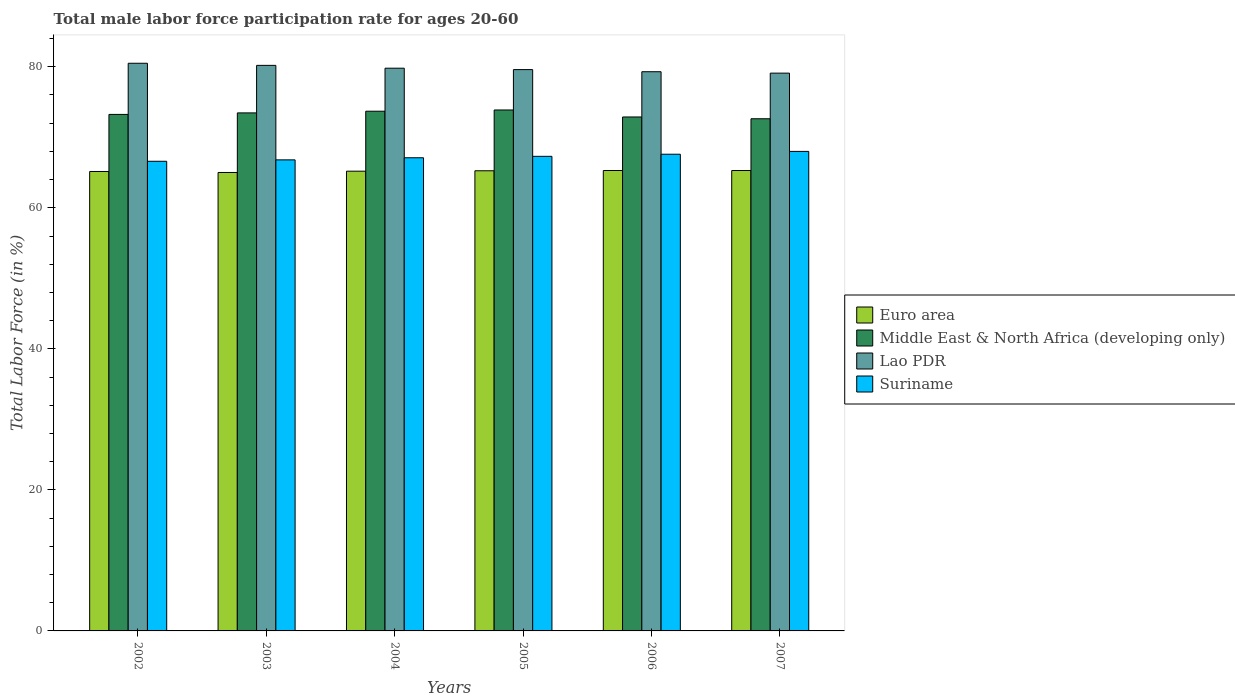How many groups of bars are there?
Your answer should be compact. 6. How many bars are there on the 5th tick from the left?
Give a very brief answer. 4. What is the male labor force participation rate in Euro area in 2003?
Make the answer very short. 65.01. Across all years, what is the maximum male labor force participation rate in Middle East & North Africa (developing only)?
Keep it short and to the point. 73.88. Across all years, what is the minimum male labor force participation rate in Suriname?
Your response must be concise. 66.6. In which year was the male labor force participation rate in Suriname maximum?
Ensure brevity in your answer.  2007. In which year was the male labor force participation rate in Euro area minimum?
Give a very brief answer. 2003. What is the total male labor force participation rate in Suriname in the graph?
Provide a succinct answer. 403.4. What is the difference between the male labor force participation rate in Middle East & North Africa (developing only) in 2006 and that in 2007?
Your answer should be very brief. 0.25. What is the difference between the male labor force participation rate in Euro area in 2006 and the male labor force participation rate in Suriname in 2004?
Keep it short and to the point. -1.81. What is the average male labor force participation rate in Suriname per year?
Your answer should be compact. 67.23. In the year 2002, what is the difference between the male labor force participation rate in Suriname and male labor force participation rate in Euro area?
Offer a terse response. 1.45. What is the ratio of the male labor force participation rate in Middle East & North Africa (developing only) in 2006 to that in 2007?
Your answer should be compact. 1. What is the difference between the highest and the second highest male labor force participation rate in Middle East & North Africa (developing only)?
Provide a short and direct response. 0.17. What is the difference between the highest and the lowest male labor force participation rate in Euro area?
Give a very brief answer. 0.28. Is it the case that in every year, the sum of the male labor force participation rate in Middle East & North Africa (developing only) and male labor force participation rate in Suriname is greater than the sum of male labor force participation rate in Lao PDR and male labor force participation rate in Euro area?
Your answer should be very brief. Yes. What does the 4th bar from the left in 2005 represents?
Your answer should be compact. Suriname. Is it the case that in every year, the sum of the male labor force participation rate in Middle East & North Africa (developing only) and male labor force participation rate in Suriname is greater than the male labor force participation rate in Euro area?
Your answer should be very brief. Yes. How many bars are there?
Offer a very short reply. 24. Are the values on the major ticks of Y-axis written in scientific E-notation?
Give a very brief answer. No. Does the graph contain any zero values?
Offer a very short reply. No. Does the graph contain grids?
Your response must be concise. No. Where does the legend appear in the graph?
Ensure brevity in your answer.  Center right. How are the legend labels stacked?
Provide a succinct answer. Vertical. What is the title of the graph?
Keep it short and to the point. Total male labor force participation rate for ages 20-60. Does "Liberia" appear as one of the legend labels in the graph?
Keep it short and to the point. No. What is the Total Labor Force (in %) of Euro area in 2002?
Your response must be concise. 65.15. What is the Total Labor Force (in %) in Middle East & North Africa (developing only) in 2002?
Your response must be concise. 73.25. What is the Total Labor Force (in %) in Lao PDR in 2002?
Your response must be concise. 80.5. What is the Total Labor Force (in %) in Suriname in 2002?
Provide a succinct answer. 66.6. What is the Total Labor Force (in %) of Euro area in 2003?
Your answer should be very brief. 65.01. What is the Total Labor Force (in %) of Middle East & North Africa (developing only) in 2003?
Offer a terse response. 73.46. What is the Total Labor Force (in %) in Lao PDR in 2003?
Provide a short and direct response. 80.2. What is the Total Labor Force (in %) in Suriname in 2003?
Ensure brevity in your answer.  66.8. What is the Total Labor Force (in %) of Euro area in 2004?
Your response must be concise. 65.2. What is the Total Labor Force (in %) in Middle East & North Africa (developing only) in 2004?
Offer a terse response. 73.7. What is the Total Labor Force (in %) in Lao PDR in 2004?
Provide a succinct answer. 79.8. What is the Total Labor Force (in %) of Suriname in 2004?
Ensure brevity in your answer.  67.1. What is the Total Labor Force (in %) of Euro area in 2005?
Keep it short and to the point. 65.25. What is the Total Labor Force (in %) of Middle East & North Africa (developing only) in 2005?
Give a very brief answer. 73.88. What is the Total Labor Force (in %) in Lao PDR in 2005?
Provide a short and direct response. 79.6. What is the Total Labor Force (in %) in Suriname in 2005?
Your answer should be compact. 67.3. What is the Total Labor Force (in %) in Euro area in 2006?
Provide a short and direct response. 65.29. What is the Total Labor Force (in %) in Middle East & North Africa (developing only) in 2006?
Provide a succinct answer. 72.88. What is the Total Labor Force (in %) in Lao PDR in 2006?
Make the answer very short. 79.3. What is the Total Labor Force (in %) in Suriname in 2006?
Ensure brevity in your answer.  67.6. What is the Total Labor Force (in %) in Euro area in 2007?
Keep it short and to the point. 65.29. What is the Total Labor Force (in %) of Middle East & North Africa (developing only) in 2007?
Your answer should be compact. 72.63. What is the Total Labor Force (in %) of Lao PDR in 2007?
Offer a terse response. 79.1. What is the Total Labor Force (in %) of Suriname in 2007?
Offer a terse response. 68. Across all years, what is the maximum Total Labor Force (in %) in Euro area?
Provide a short and direct response. 65.29. Across all years, what is the maximum Total Labor Force (in %) of Middle East & North Africa (developing only)?
Make the answer very short. 73.88. Across all years, what is the maximum Total Labor Force (in %) of Lao PDR?
Provide a short and direct response. 80.5. Across all years, what is the minimum Total Labor Force (in %) in Euro area?
Make the answer very short. 65.01. Across all years, what is the minimum Total Labor Force (in %) of Middle East & North Africa (developing only)?
Ensure brevity in your answer.  72.63. Across all years, what is the minimum Total Labor Force (in %) of Lao PDR?
Your answer should be very brief. 79.1. Across all years, what is the minimum Total Labor Force (in %) in Suriname?
Your answer should be compact. 66.6. What is the total Total Labor Force (in %) in Euro area in the graph?
Your response must be concise. 391.19. What is the total Total Labor Force (in %) of Middle East & North Africa (developing only) in the graph?
Give a very brief answer. 439.79. What is the total Total Labor Force (in %) of Lao PDR in the graph?
Offer a terse response. 478.5. What is the total Total Labor Force (in %) in Suriname in the graph?
Give a very brief answer. 403.4. What is the difference between the Total Labor Force (in %) in Euro area in 2002 and that in 2003?
Offer a terse response. 0.14. What is the difference between the Total Labor Force (in %) of Middle East & North Africa (developing only) in 2002 and that in 2003?
Give a very brief answer. -0.22. What is the difference between the Total Labor Force (in %) of Suriname in 2002 and that in 2003?
Your response must be concise. -0.2. What is the difference between the Total Labor Force (in %) in Euro area in 2002 and that in 2004?
Your answer should be compact. -0.04. What is the difference between the Total Labor Force (in %) of Middle East & North Africa (developing only) in 2002 and that in 2004?
Give a very brief answer. -0.46. What is the difference between the Total Labor Force (in %) of Suriname in 2002 and that in 2004?
Provide a short and direct response. -0.5. What is the difference between the Total Labor Force (in %) of Euro area in 2002 and that in 2005?
Your answer should be very brief. -0.1. What is the difference between the Total Labor Force (in %) in Middle East & North Africa (developing only) in 2002 and that in 2005?
Provide a short and direct response. -0.63. What is the difference between the Total Labor Force (in %) in Euro area in 2002 and that in 2006?
Your response must be concise. -0.14. What is the difference between the Total Labor Force (in %) of Middle East & North Africa (developing only) in 2002 and that in 2006?
Your answer should be very brief. 0.36. What is the difference between the Total Labor Force (in %) in Suriname in 2002 and that in 2006?
Ensure brevity in your answer.  -1. What is the difference between the Total Labor Force (in %) in Euro area in 2002 and that in 2007?
Your response must be concise. -0.14. What is the difference between the Total Labor Force (in %) in Middle East & North Africa (developing only) in 2002 and that in 2007?
Provide a succinct answer. 0.62. What is the difference between the Total Labor Force (in %) in Lao PDR in 2002 and that in 2007?
Your answer should be very brief. 1.4. What is the difference between the Total Labor Force (in %) in Euro area in 2003 and that in 2004?
Ensure brevity in your answer.  -0.18. What is the difference between the Total Labor Force (in %) in Middle East & North Africa (developing only) in 2003 and that in 2004?
Ensure brevity in your answer.  -0.24. What is the difference between the Total Labor Force (in %) in Euro area in 2003 and that in 2005?
Your response must be concise. -0.24. What is the difference between the Total Labor Force (in %) in Middle East & North Africa (developing only) in 2003 and that in 2005?
Make the answer very short. -0.41. What is the difference between the Total Labor Force (in %) in Lao PDR in 2003 and that in 2005?
Give a very brief answer. 0.6. What is the difference between the Total Labor Force (in %) in Suriname in 2003 and that in 2005?
Make the answer very short. -0.5. What is the difference between the Total Labor Force (in %) in Euro area in 2003 and that in 2006?
Your answer should be very brief. -0.28. What is the difference between the Total Labor Force (in %) in Middle East & North Africa (developing only) in 2003 and that in 2006?
Give a very brief answer. 0.58. What is the difference between the Total Labor Force (in %) in Lao PDR in 2003 and that in 2006?
Your response must be concise. 0.9. What is the difference between the Total Labor Force (in %) in Suriname in 2003 and that in 2006?
Keep it short and to the point. -0.8. What is the difference between the Total Labor Force (in %) of Euro area in 2003 and that in 2007?
Give a very brief answer. -0.28. What is the difference between the Total Labor Force (in %) in Middle East & North Africa (developing only) in 2003 and that in 2007?
Your answer should be very brief. 0.83. What is the difference between the Total Labor Force (in %) in Lao PDR in 2003 and that in 2007?
Offer a very short reply. 1.1. What is the difference between the Total Labor Force (in %) in Euro area in 2004 and that in 2005?
Your response must be concise. -0.06. What is the difference between the Total Labor Force (in %) of Middle East & North Africa (developing only) in 2004 and that in 2005?
Provide a short and direct response. -0.17. What is the difference between the Total Labor Force (in %) in Suriname in 2004 and that in 2005?
Give a very brief answer. -0.2. What is the difference between the Total Labor Force (in %) of Euro area in 2004 and that in 2006?
Provide a succinct answer. -0.1. What is the difference between the Total Labor Force (in %) in Middle East & North Africa (developing only) in 2004 and that in 2006?
Ensure brevity in your answer.  0.82. What is the difference between the Total Labor Force (in %) in Suriname in 2004 and that in 2006?
Provide a short and direct response. -0.5. What is the difference between the Total Labor Force (in %) in Euro area in 2004 and that in 2007?
Offer a terse response. -0.09. What is the difference between the Total Labor Force (in %) in Middle East & North Africa (developing only) in 2004 and that in 2007?
Offer a very short reply. 1.07. What is the difference between the Total Labor Force (in %) of Lao PDR in 2004 and that in 2007?
Ensure brevity in your answer.  0.7. What is the difference between the Total Labor Force (in %) of Euro area in 2005 and that in 2006?
Your answer should be very brief. -0.04. What is the difference between the Total Labor Force (in %) in Middle East & North Africa (developing only) in 2005 and that in 2006?
Offer a very short reply. 0.99. What is the difference between the Total Labor Force (in %) of Lao PDR in 2005 and that in 2006?
Make the answer very short. 0.3. What is the difference between the Total Labor Force (in %) in Suriname in 2005 and that in 2006?
Make the answer very short. -0.3. What is the difference between the Total Labor Force (in %) in Euro area in 2005 and that in 2007?
Ensure brevity in your answer.  -0.04. What is the difference between the Total Labor Force (in %) of Middle East & North Africa (developing only) in 2005 and that in 2007?
Ensure brevity in your answer.  1.25. What is the difference between the Total Labor Force (in %) of Lao PDR in 2005 and that in 2007?
Offer a terse response. 0.5. What is the difference between the Total Labor Force (in %) in Suriname in 2005 and that in 2007?
Provide a short and direct response. -0.7. What is the difference between the Total Labor Force (in %) in Euro area in 2006 and that in 2007?
Offer a terse response. 0. What is the difference between the Total Labor Force (in %) in Middle East & North Africa (developing only) in 2006 and that in 2007?
Your answer should be compact. 0.25. What is the difference between the Total Labor Force (in %) of Lao PDR in 2006 and that in 2007?
Your answer should be very brief. 0.2. What is the difference between the Total Labor Force (in %) of Euro area in 2002 and the Total Labor Force (in %) of Middle East & North Africa (developing only) in 2003?
Ensure brevity in your answer.  -8.31. What is the difference between the Total Labor Force (in %) in Euro area in 2002 and the Total Labor Force (in %) in Lao PDR in 2003?
Keep it short and to the point. -15.05. What is the difference between the Total Labor Force (in %) in Euro area in 2002 and the Total Labor Force (in %) in Suriname in 2003?
Your response must be concise. -1.65. What is the difference between the Total Labor Force (in %) of Middle East & North Africa (developing only) in 2002 and the Total Labor Force (in %) of Lao PDR in 2003?
Provide a succinct answer. -6.95. What is the difference between the Total Labor Force (in %) of Middle East & North Africa (developing only) in 2002 and the Total Labor Force (in %) of Suriname in 2003?
Give a very brief answer. 6.45. What is the difference between the Total Labor Force (in %) in Euro area in 2002 and the Total Labor Force (in %) in Middle East & North Africa (developing only) in 2004?
Provide a short and direct response. -8.55. What is the difference between the Total Labor Force (in %) in Euro area in 2002 and the Total Labor Force (in %) in Lao PDR in 2004?
Provide a succinct answer. -14.65. What is the difference between the Total Labor Force (in %) of Euro area in 2002 and the Total Labor Force (in %) of Suriname in 2004?
Your response must be concise. -1.95. What is the difference between the Total Labor Force (in %) of Middle East & North Africa (developing only) in 2002 and the Total Labor Force (in %) of Lao PDR in 2004?
Keep it short and to the point. -6.55. What is the difference between the Total Labor Force (in %) in Middle East & North Africa (developing only) in 2002 and the Total Labor Force (in %) in Suriname in 2004?
Your response must be concise. 6.15. What is the difference between the Total Labor Force (in %) in Lao PDR in 2002 and the Total Labor Force (in %) in Suriname in 2004?
Offer a terse response. 13.4. What is the difference between the Total Labor Force (in %) in Euro area in 2002 and the Total Labor Force (in %) in Middle East & North Africa (developing only) in 2005?
Ensure brevity in your answer.  -8.72. What is the difference between the Total Labor Force (in %) of Euro area in 2002 and the Total Labor Force (in %) of Lao PDR in 2005?
Keep it short and to the point. -14.45. What is the difference between the Total Labor Force (in %) in Euro area in 2002 and the Total Labor Force (in %) in Suriname in 2005?
Ensure brevity in your answer.  -2.15. What is the difference between the Total Labor Force (in %) in Middle East & North Africa (developing only) in 2002 and the Total Labor Force (in %) in Lao PDR in 2005?
Give a very brief answer. -6.35. What is the difference between the Total Labor Force (in %) in Middle East & North Africa (developing only) in 2002 and the Total Labor Force (in %) in Suriname in 2005?
Keep it short and to the point. 5.95. What is the difference between the Total Labor Force (in %) of Lao PDR in 2002 and the Total Labor Force (in %) of Suriname in 2005?
Your answer should be compact. 13.2. What is the difference between the Total Labor Force (in %) in Euro area in 2002 and the Total Labor Force (in %) in Middle East & North Africa (developing only) in 2006?
Keep it short and to the point. -7.73. What is the difference between the Total Labor Force (in %) in Euro area in 2002 and the Total Labor Force (in %) in Lao PDR in 2006?
Offer a very short reply. -14.15. What is the difference between the Total Labor Force (in %) in Euro area in 2002 and the Total Labor Force (in %) in Suriname in 2006?
Make the answer very short. -2.45. What is the difference between the Total Labor Force (in %) in Middle East & North Africa (developing only) in 2002 and the Total Labor Force (in %) in Lao PDR in 2006?
Provide a short and direct response. -6.05. What is the difference between the Total Labor Force (in %) of Middle East & North Africa (developing only) in 2002 and the Total Labor Force (in %) of Suriname in 2006?
Keep it short and to the point. 5.65. What is the difference between the Total Labor Force (in %) in Euro area in 2002 and the Total Labor Force (in %) in Middle East & North Africa (developing only) in 2007?
Offer a very short reply. -7.48. What is the difference between the Total Labor Force (in %) in Euro area in 2002 and the Total Labor Force (in %) in Lao PDR in 2007?
Provide a succinct answer. -13.95. What is the difference between the Total Labor Force (in %) in Euro area in 2002 and the Total Labor Force (in %) in Suriname in 2007?
Your answer should be very brief. -2.85. What is the difference between the Total Labor Force (in %) in Middle East & North Africa (developing only) in 2002 and the Total Labor Force (in %) in Lao PDR in 2007?
Your response must be concise. -5.85. What is the difference between the Total Labor Force (in %) in Middle East & North Africa (developing only) in 2002 and the Total Labor Force (in %) in Suriname in 2007?
Provide a succinct answer. 5.25. What is the difference between the Total Labor Force (in %) of Euro area in 2003 and the Total Labor Force (in %) of Middle East & North Africa (developing only) in 2004?
Your response must be concise. -8.69. What is the difference between the Total Labor Force (in %) of Euro area in 2003 and the Total Labor Force (in %) of Lao PDR in 2004?
Your answer should be compact. -14.79. What is the difference between the Total Labor Force (in %) in Euro area in 2003 and the Total Labor Force (in %) in Suriname in 2004?
Provide a succinct answer. -2.09. What is the difference between the Total Labor Force (in %) of Middle East & North Africa (developing only) in 2003 and the Total Labor Force (in %) of Lao PDR in 2004?
Make the answer very short. -6.34. What is the difference between the Total Labor Force (in %) in Middle East & North Africa (developing only) in 2003 and the Total Labor Force (in %) in Suriname in 2004?
Offer a very short reply. 6.36. What is the difference between the Total Labor Force (in %) in Euro area in 2003 and the Total Labor Force (in %) in Middle East & North Africa (developing only) in 2005?
Your response must be concise. -8.86. What is the difference between the Total Labor Force (in %) of Euro area in 2003 and the Total Labor Force (in %) of Lao PDR in 2005?
Ensure brevity in your answer.  -14.59. What is the difference between the Total Labor Force (in %) in Euro area in 2003 and the Total Labor Force (in %) in Suriname in 2005?
Your answer should be compact. -2.29. What is the difference between the Total Labor Force (in %) in Middle East & North Africa (developing only) in 2003 and the Total Labor Force (in %) in Lao PDR in 2005?
Keep it short and to the point. -6.14. What is the difference between the Total Labor Force (in %) of Middle East & North Africa (developing only) in 2003 and the Total Labor Force (in %) of Suriname in 2005?
Your answer should be compact. 6.16. What is the difference between the Total Labor Force (in %) of Euro area in 2003 and the Total Labor Force (in %) of Middle East & North Africa (developing only) in 2006?
Your response must be concise. -7.87. What is the difference between the Total Labor Force (in %) of Euro area in 2003 and the Total Labor Force (in %) of Lao PDR in 2006?
Keep it short and to the point. -14.29. What is the difference between the Total Labor Force (in %) in Euro area in 2003 and the Total Labor Force (in %) in Suriname in 2006?
Ensure brevity in your answer.  -2.59. What is the difference between the Total Labor Force (in %) in Middle East & North Africa (developing only) in 2003 and the Total Labor Force (in %) in Lao PDR in 2006?
Make the answer very short. -5.84. What is the difference between the Total Labor Force (in %) in Middle East & North Africa (developing only) in 2003 and the Total Labor Force (in %) in Suriname in 2006?
Your answer should be very brief. 5.86. What is the difference between the Total Labor Force (in %) in Euro area in 2003 and the Total Labor Force (in %) in Middle East & North Africa (developing only) in 2007?
Your response must be concise. -7.62. What is the difference between the Total Labor Force (in %) of Euro area in 2003 and the Total Labor Force (in %) of Lao PDR in 2007?
Your answer should be compact. -14.09. What is the difference between the Total Labor Force (in %) in Euro area in 2003 and the Total Labor Force (in %) in Suriname in 2007?
Your answer should be compact. -2.99. What is the difference between the Total Labor Force (in %) of Middle East & North Africa (developing only) in 2003 and the Total Labor Force (in %) of Lao PDR in 2007?
Give a very brief answer. -5.64. What is the difference between the Total Labor Force (in %) in Middle East & North Africa (developing only) in 2003 and the Total Labor Force (in %) in Suriname in 2007?
Offer a terse response. 5.46. What is the difference between the Total Labor Force (in %) of Euro area in 2004 and the Total Labor Force (in %) of Middle East & North Africa (developing only) in 2005?
Offer a very short reply. -8.68. What is the difference between the Total Labor Force (in %) of Euro area in 2004 and the Total Labor Force (in %) of Lao PDR in 2005?
Your response must be concise. -14.4. What is the difference between the Total Labor Force (in %) in Euro area in 2004 and the Total Labor Force (in %) in Suriname in 2005?
Your answer should be compact. -2.1. What is the difference between the Total Labor Force (in %) in Middle East & North Africa (developing only) in 2004 and the Total Labor Force (in %) in Lao PDR in 2005?
Keep it short and to the point. -5.9. What is the difference between the Total Labor Force (in %) in Middle East & North Africa (developing only) in 2004 and the Total Labor Force (in %) in Suriname in 2005?
Provide a short and direct response. 6.4. What is the difference between the Total Labor Force (in %) in Euro area in 2004 and the Total Labor Force (in %) in Middle East & North Africa (developing only) in 2006?
Keep it short and to the point. -7.69. What is the difference between the Total Labor Force (in %) of Euro area in 2004 and the Total Labor Force (in %) of Lao PDR in 2006?
Provide a short and direct response. -14.1. What is the difference between the Total Labor Force (in %) of Euro area in 2004 and the Total Labor Force (in %) of Suriname in 2006?
Make the answer very short. -2.4. What is the difference between the Total Labor Force (in %) of Middle East & North Africa (developing only) in 2004 and the Total Labor Force (in %) of Lao PDR in 2006?
Offer a very short reply. -5.6. What is the difference between the Total Labor Force (in %) in Middle East & North Africa (developing only) in 2004 and the Total Labor Force (in %) in Suriname in 2006?
Offer a very short reply. 6.1. What is the difference between the Total Labor Force (in %) of Lao PDR in 2004 and the Total Labor Force (in %) of Suriname in 2006?
Provide a short and direct response. 12.2. What is the difference between the Total Labor Force (in %) of Euro area in 2004 and the Total Labor Force (in %) of Middle East & North Africa (developing only) in 2007?
Offer a terse response. -7.43. What is the difference between the Total Labor Force (in %) in Euro area in 2004 and the Total Labor Force (in %) in Lao PDR in 2007?
Keep it short and to the point. -13.9. What is the difference between the Total Labor Force (in %) of Euro area in 2004 and the Total Labor Force (in %) of Suriname in 2007?
Make the answer very short. -2.8. What is the difference between the Total Labor Force (in %) of Middle East & North Africa (developing only) in 2004 and the Total Labor Force (in %) of Lao PDR in 2007?
Ensure brevity in your answer.  -5.4. What is the difference between the Total Labor Force (in %) of Middle East & North Africa (developing only) in 2004 and the Total Labor Force (in %) of Suriname in 2007?
Provide a succinct answer. 5.7. What is the difference between the Total Labor Force (in %) in Lao PDR in 2004 and the Total Labor Force (in %) in Suriname in 2007?
Offer a terse response. 11.8. What is the difference between the Total Labor Force (in %) of Euro area in 2005 and the Total Labor Force (in %) of Middle East & North Africa (developing only) in 2006?
Ensure brevity in your answer.  -7.63. What is the difference between the Total Labor Force (in %) in Euro area in 2005 and the Total Labor Force (in %) in Lao PDR in 2006?
Offer a very short reply. -14.05. What is the difference between the Total Labor Force (in %) of Euro area in 2005 and the Total Labor Force (in %) of Suriname in 2006?
Make the answer very short. -2.35. What is the difference between the Total Labor Force (in %) of Middle East & North Africa (developing only) in 2005 and the Total Labor Force (in %) of Lao PDR in 2006?
Your answer should be very brief. -5.42. What is the difference between the Total Labor Force (in %) in Middle East & North Africa (developing only) in 2005 and the Total Labor Force (in %) in Suriname in 2006?
Ensure brevity in your answer.  6.28. What is the difference between the Total Labor Force (in %) of Lao PDR in 2005 and the Total Labor Force (in %) of Suriname in 2006?
Your response must be concise. 12. What is the difference between the Total Labor Force (in %) in Euro area in 2005 and the Total Labor Force (in %) in Middle East & North Africa (developing only) in 2007?
Offer a terse response. -7.38. What is the difference between the Total Labor Force (in %) of Euro area in 2005 and the Total Labor Force (in %) of Lao PDR in 2007?
Your response must be concise. -13.85. What is the difference between the Total Labor Force (in %) in Euro area in 2005 and the Total Labor Force (in %) in Suriname in 2007?
Ensure brevity in your answer.  -2.75. What is the difference between the Total Labor Force (in %) in Middle East & North Africa (developing only) in 2005 and the Total Labor Force (in %) in Lao PDR in 2007?
Provide a succinct answer. -5.22. What is the difference between the Total Labor Force (in %) in Middle East & North Africa (developing only) in 2005 and the Total Labor Force (in %) in Suriname in 2007?
Make the answer very short. 5.88. What is the difference between the Total Labor Force (in %) of Lao PDR in 2005 and the Total Labor Force (in %) of Suriname in 2007?
Give a very brief answer. 11.6. What is the difference between the Total Labor Force (in %) in Euro area in 2006 and the Total Labor Force (in %) in Middle East & North Africa (developing only) in 2007?
Provide a short and direct response. -7.34. What is the difference between the Total Labor Force (in %) of Euro area in 2006 and the Total Labor Force (in %) of Lao PDR in 2007?
Offer a very short reply. -13.81. What is the difference between the Total Labor Force (in %) in Euro area in 2006 and the Total Labor Force (in %) in Suriname in 2007?
Provide a succinct answer. -2.71. What is the difference between the Total Labor Force (in %) of Middle East & North Africa (developing only) in 2006 and the Total Labor Force (in %) of Lao PDR in 2007?
Provide a short and direct response. -6.22. What is the difference between the Total Labor Force (in %) of Middle East & North Africa (developing only) in 2006 and the Total Labor Force (in %) of Suriname in 2007?
Offer a terse response. 4.88. What is the average Total Labor Force (in %) in Euro area per year?
Provide a succinct answer. 65.2. What is the average Total Labor Force (in %) of Middle East & North Africa (developing only) per year?
Make the answer very short. 73.3. What is the average Total Labor Force (in %) in Lao PDR per year?
Keep it short and to the point. 79.75. What is the average Total Labor Force (in %) in Suriname per year?
Offer a very short reply. 67.23. In the year 2002, what is the difference between the Total Labor Force (in %) in Euro area and Total Labor Force (in %) in Middle East & North Africa (developing only)?
Offer a terse response. -8.09. In the year 2002, what is the difference between the Total Labor Force (in %) in Euro area and Total Labor Force (in %) in Lao PDR?
Offer a very short reply. -15.35. In the year 2002, what is the difference between the Total Labor Force (in %) of Euro area and Total Labor Force (in %) of Suriname?
Offer a very short reply. -1.45. In the year 2002, what is the difference between the Total Labor Force (in %) in Middle East & North Africa (developing only) and Total Labor Force (in %) in Lao PDR?
Give a very brief answer. -7.25. In the year 2002, what is the difference between the Total Labor Force (in %) of Middle East & North Africa (developing only) and Total Labor Force (in %) of Suriname?
Offer a very short reply. 6.65. In the year 2003, what is the difference between the Total Labor Force (in %) of Euro area and Total Labor Force (in %) of Middle East & North Africa (developing only)?
Provide a short and direct response. -8.45. In the year 2003, what is the difference between the Total Labor Force (in %) in Euro area and Total Labor Force (in %) in Lao PDR?
Provide a short and direct response. -15.19. In the year 2003, what is the difference between the Total Labor Force (in %) of Euro area and Total Labor Force (in %) of Suriname?
Make the answer very short. -1.79. In the year 2003, what is the difference between the Total Labor Force (in %) in Middle East & North Africa (developing only) and Total Labor Force (in %) in Lao PDR?
Make the answer very short. -6.74. In the year 2003, what is the difference between the Total Labor Force (in %) in Middle East & North Africa (developing only) and Total Labor Force (in %) in Suriname?
Give a very brief answer. 6.66. In the year 2004, what is the difference between the Total Labor Force (in %) of Euro area and Total Labor Force (in %) of Middle East & North Africa (developing only)?
Make the answer very short. -8.51. In the year 2004, what is the difference between the Total Labor Force (in %) of Euro area and Total Labor Force (in %) of Lao PDR?
Give a very brief answer. -14.6. In the year 2004, what is the difference between the Total Labor Force (in %) in Euro area and Total Labor Force (in %) in Suriname?
Your answer should be very brief. -1.9. In the year 2004, what is the difference between the Total Labor Force (in %) of Middle East & North Africa (developing only) and Total Labor Force (in %) of Lao PDR?
Your answer should be very brief. -6.1. In the year 2004, what is the difference between the Total Labor Force (in %) in Middle East & North Africa (developing only) and Total Labor Force (in %) in Suriname?
Offer a very short reply. 6.6. In the year 2004, what is the difference between the Total Labor Force (in %) of Lao PDR and Total Labor Force (in %) of Suriname?
Keep it short and to the point. 12.7. In the year 2005, what is the difference between the Total Labor Force (in %) in Euro area and Total Labor Force (in %) in Middle East & North Africa (developing only)?
Provide a short and direct response. -8.62. In the year 2005, what is the difference between the Total Labor Force (in %) in Euro area and Total Labor Force (in %) in Lao PDR?
Ensure brevity in your answer.  -14.35. In the year 2005, what is the difference between the Total Labor Force (in %) in Euro area and Total Labor Force (in %) in Suriname?
Your response must be concise. -2.05. In the year 2005, what is the difference between the Total Labor Force (in %) of Middle East & North Africa (developing only) and Total Labor Force (in %) of Lao PDR?
Ensure brevity in your answer.  -5.72. In the year 2005, what is the difference between the Total Labor Force (in %) in Middle East & North Africa (developing only) and Total Labor Force (in %) in Suriname?
Provide a short and direct response. 6.58. In the year 2005, what is the difference between the Total Labor Force (in %) in Lao PDR and Total Labor Force (in %) in Suriname?
Your answer should be very brief. 12.3. In the year 2006, what is the difference between the Total Labor Force (in %) in Euro area and Total Labor Force (in %) in Middle East & North Africa (developing only)?
Offer a very short reply. -7.59. In the year 2006, what is the difference between the Total Labor Force (in %) in Euro area and Total Labor Force (in %) in Lao PDR?
Offer a very short reply. -14.01. In the year 2006, what is the difference between the Total Labor Force (in %) in Euro area and Total Labor Force (in %) in Suriname?
Provide a succinct answer. -2.31. In the year 2006, what is the difference between the Total Labor Force (in %) in Middle East & North Africa (developing only) and Total Labor Force (in %) in Lao PDR?
Your answer should be compact. -6.42. In the year 2006, what is the difference between the Total Labor Force (in %) in Middle East & North Africa (developing only) and Total Labor Force (in %) in Suriname?
Provide a succinct answer. 5.28. In the year 2006, what is the difference between the Total Labor Force (in %) of Lao PDR and Total Labor Force (in %) of Suriname?
Your answer should be very brief. 11.7. In the year 2007, what is the difference between the Total Labor Force (in %) in Euro area and Total Labor Force (in %) in Middle East & North Africa (developing only)?
Offer a very short reply. -7.34. In the year 2007, what is the difference between the Total Labor Force (in %) of Euro area and Total Labor Force (in %) of Lao PDR?
Offer a very short reply. -13.81. In the year 2007, what is the difference between the Total Labor Force (in %) in Euro area and Total Labor Force (in %) in Suriname?
Ensure brevity in your answer.  -2.71. In the year 2007, what is the difference between the Total Labor Force (in %) in Middle East & North Africa (developing only) and Total Labor Force (in %) in Lao PDR?
Provide a succinct answer. -6.47. In the year 2007, what is the difference between the Total Labor Force (in %) of Middle East & North Africa (developing only) and Total Labor Force (in %) of Suriname?
Make the answer very short. 4.63. In the year 2007, what is the difference between the Total Labor Force (in %) of Lao PDR and Total Labor Force (in %) of Suriname?
Provide a succinct answer. 11.1. What is the ratio of the Total Labor Force (in %) in Middle East & North Africa (developing only) in 2002 to that in 2004?
Provide a succinct answer. 0.99. What is the ratio of the Total Labor Force (in %) in Lao PDR in 2002 to that in 2004?
Make the answer very short. 1.01. What is the ratio of the Total Labor Force (in %) of Lao PDR in 2002 to that in 2005?
Your response must be concise. 1.01. What is the ratio of the Total Labor Force (in %) of Euro area in 2002 to that in 2006?
Provide a succinct answer. 1. What is the ratio of the Total Labor Force (in %) in Middle East & North Africa (developing only) in 2002 to that in 2006?
Offer a terse response. 1. What is the ratio of the Total Labor Force (in %) of Lao PDR in 2002 to that in 2006?
Offer a terse response. 1.02. What is the ratio of the Total Labor Force (in %) in Suriname in 2002 to that in 2006?
Offer a very short reply. 0.99. What is the ratio of the Total Labor Force (in %) in Middle East & North Africa (developing only) in 2002 to that in 2007?
Provide a succinct answer. 1.01. What is the ratio of the Total Labor Force (in %) of Lao PDR in 2002 to that in 2007?
Keep it short and to the point. 1.02. What is the ratio of the Total Labor Force (in %) in Suriname in 2002 to that in 2007?
Offer a terse response. 0.98. What is the ratio of the Total Labor Force (in %) in Lao PDR in 2003 to that in 2004?
Ensure brevity in your answer.  1. What is the ratio of the Total Labor Force (in %) of Lao PDR in 2003 to that in 2005?
Make the answer very short. 1.01. What is the ratio of the Total Labor Force (in %) in Suriname in 2003 to that in 2005?
Ensure brevity in your answer.  0.99. What is the ratio of the Total Labor Force (in %) of Euro area in 2003 to that in 2006?
Ensure brevity in your answer.  1. What is the ratio of the Total Labor Force (in %) in Middle East & North Africa (developing only) in 2003 to that in 2006?
Keep it short and to the point. 1.01. What is the ratio of the Total Labor Force (in %) of Lao PDR in 2003 to that in 2006?
Your answer should be very brief. 1.01. What is the ratio of the Total Labor Force (in %) in Suriname in 2003 to that in 2006?
Ensure brevity in your answer.  0.99. What is the ratio of the Total Labor Force (in %) in Middle East & North Africa (developing only) in 2003 to that in 2007?
Your response must be concise. 1.01. What is the ratio of the Total Labor Force (in %) of Lao PDR in 2003 to that in 2007?
Keep it short and to the point. 1.01. What is the ratio of the Total Labor Force (in %) of Suriname in 2003 to that in 2007?
Provide a short and direct response. 0.98. What is the ratio of the Total Labor Force (in %) in Suriname in 2004 to that in 2005?
Make the answer very short. 1. What is the ratio of the Total Labor Force (in %) in Euro area in 2004 to that in 2006?
Provide a short and direct response. 1. What is the ratio of the Total Labor Force (in %) of Middle East & North Africa (developing only) in 2004 to that in 2006?
Offer a terse response. 1.01. What is the ratio of the Total Labor Force (in %) of Lao PDR in 2004 to that in 2006?
Provide a short and direct response. 1.01. What is the ratio of the Total Labor Force (in %) of Middle East & North Africa (developing only) in 2004 to that in 2007?
Give a very brief answer. 1.01. What is the ratio of the Total Labor Force (in %) of Lao PDR in 2004 to that in 2007?
Your response must be concise. 1.01. What is the ratio of the Total Labor Force (in %) in Suriname in 2004 to that in 2007?
Provide a short and direct response. 0.99. What is the ratio of the Total Labor Force (in %) of Euro area in 2005 to that in 2006?
Provide a short and direct response. 1. What is the ratio of the Total Labor Force (in %) in Middle East & North Africa (developing only) in 2005 to that in 2006?
Your answer should be very brief. 1.01. What is the ratio of the Total Labor Force (in %) in Lao PDR in 2005 to that in 2006?
Make the answer very short. 1. What is the ratio of the Total Labor Force (in %) of Suriname in 2005 to that in 2006?
Ensure brevity in your answer.  1. What is the ratio of the Total Labor Force (in %) in Middle East & North Africa (developing only) in 2005 to that in 2007?
Offer a very short reply. 1.02. What is the ratio of the Total Labor Force (in %) in Suriname in 2006 to that in 2007?
Your response must be concise. 0.99. What is the difference between the highest and the second highest Total Labor Force (in %) in Euro area?
Provide a succinct answer. 0. What is the difference between the highest and the second highest Total Labor Force (in %) in Middle East & North Africa (developing only)?
Give a very brief answer. 0.17. What is the difference between the highest and the second highest Total Labor Force (in %) of Suriname?
Make the answer very short. 0.4. What is the difference between the highest and the lowest Total Labor Force (in %) of Euro area?
Your answer should be compact. 0.28. What is the difference between the highest and the lowest Total Labor Force (in %) in Middle East & North Africa (developing only)?
Your answer should be very brief. 1.25. What is the difference between the highest and the lowest Total Labor Force (in %) in Suriname?
Your answer should be very brief. 1.4. 